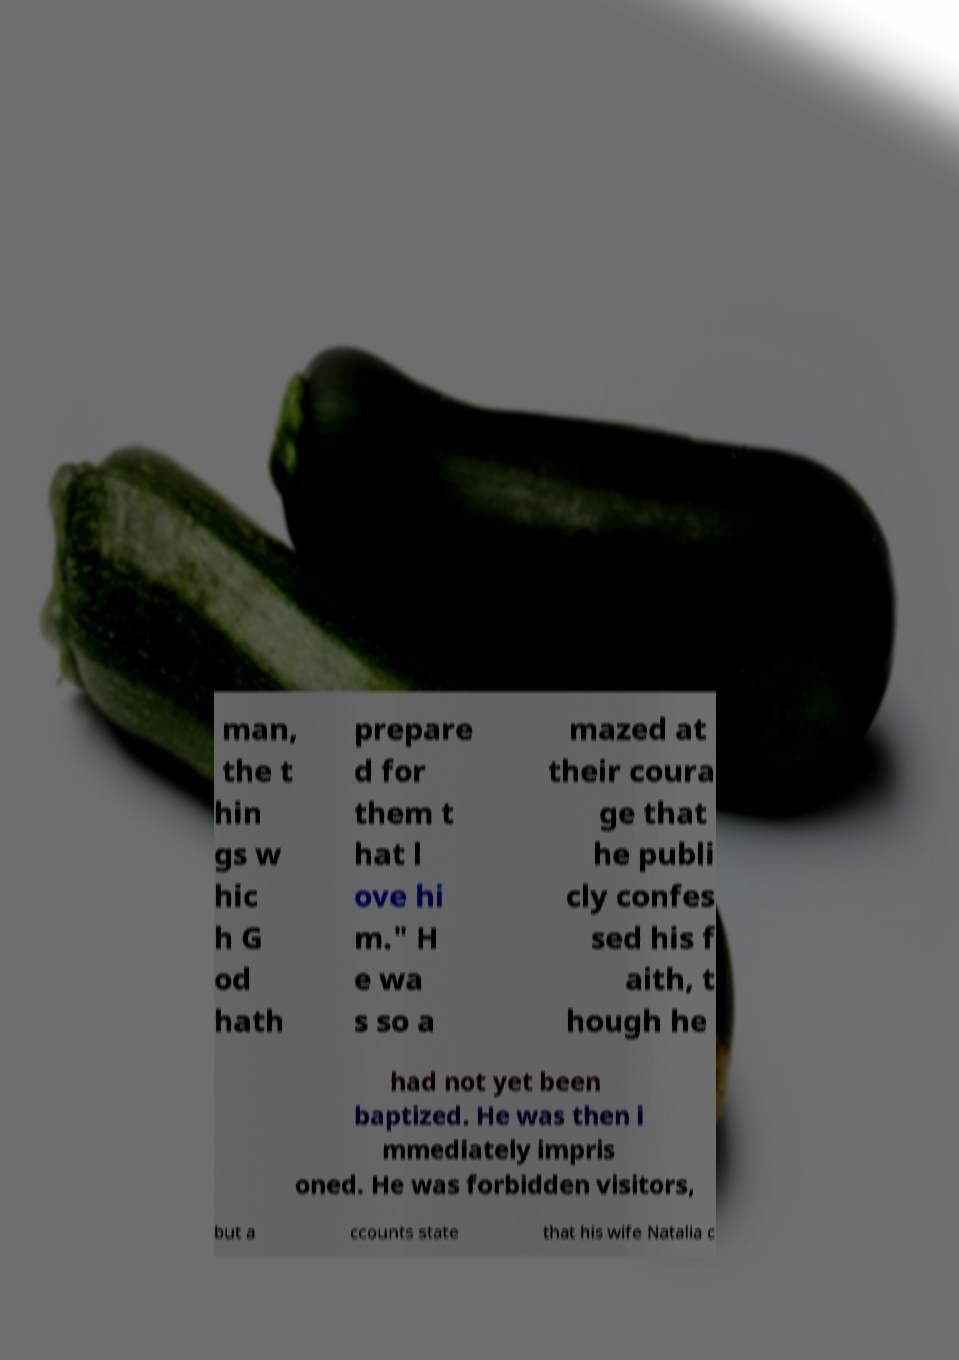Can you accurately transcribe the text from the provided image for me? man, the t hin gs w hic h G od hath prepare d for them t hat l ove hi m." H e wa s so a mazed at their coura ge that he publi cly confes sed his f aith, t hough he had not yet been baptized. He was then i mmediately impris oned. He was forbidden visitors, but a ccounts state that his wife Natalia c 